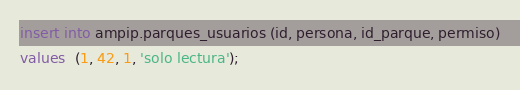<code> <loc_0><loc_0><loc_500><loc_500><_SQL_>insert into ampip.parques_usuarios (id, persona, id_parque, permiso)
values  (1, 42, 1, 'solo lectura');</code> 